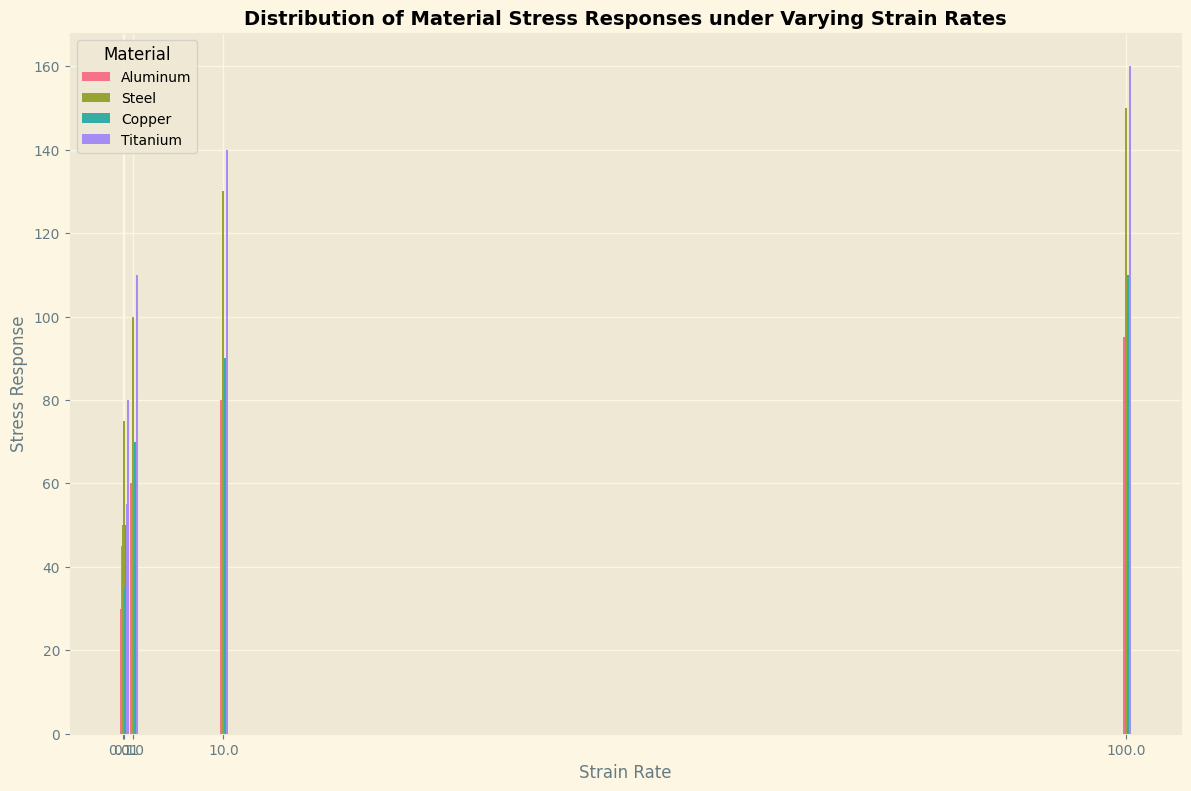What strain rate results in the highest stress response for Titanium? The highest bar representing Titanium is observed at the strain rate of 100, which has a stress response of 160.
Answer: 100 Between Aluminum and Copper, which material has higher stress responses at lower strain rates (0.01 and 0.1)? At a strain rate of 0.01, Aluminum has a stress response of 30 and Copper has 35. At 0.1, Aluminum has 45 and Copper has 50. Copper has higher stress responses at both 0.01 and 0.1 strain rates.
Answer: Copper What is the average stress response of Steel across all strain rates? The stress responses of Steel at strain rates are 50, 75, 100, 130, and 150. The average is calculated as (50 + 75 + 100 + 130 + 150) / 5 = 101.
Answer: 101 Which material shows the least increase in stress response from strain rate 1 to strain rate 10? The increase from strain rate 1 to 10: Aluminum (60 to 80, increase by 20), Steel (100 to 130, increase by 30), Copper (70 to 90, increase by 20), Titanium (110 to 140, increase by 30). Both Aluminum and Copper show the least increase of 20 units.
Answer: Aluminum and Copper Which strain rate category has the highest variability in stress response among all materials? At strain rate 100, the stress responses are Aluminum (95), Steel (150), Copper (110), Titanium (160). The range is 160 - 95 = 65, which is the highest variability compared to other strain rates.
Answer: 100 What is the difference in stress response for Aluminum between the lowest and highest strain rates? The stress response for Aluminum at the lowest strain rate (0.01) is 30, and at the highest strain rate (100) is 95. The difference is 95 - 30 = 65.
Answer: 65 Does the trend of stress response increasing with strain rate hold for all materials? Observing the bars, each material (Aluminum, Steel, Copper, Titanium) shows increasing heights of bars with increasing strain rates, indicating that stress response increases for all materials.
Answer: Yes Which material has the highest average stress response across all strain rates? Sum of stress responses divided by 5 for each material: Aluminum (310/5), Steel (505/5), Copper (355/5), Titanium (545/5). The highest average is Titanium with 545 / 5 = 109.
Answer: Titanium 